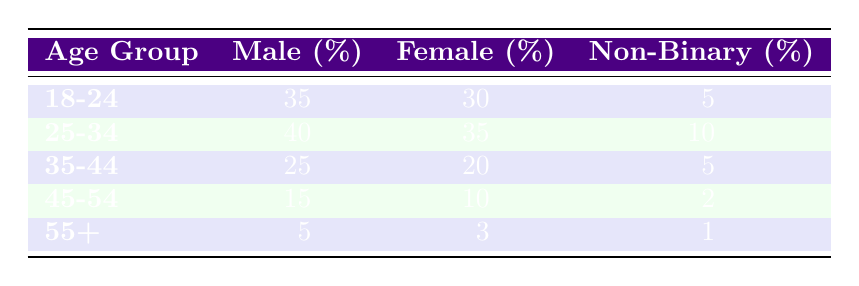What is the male participation rate in the 18-24 age group? The table shows the male participation percentage specifically for the 18-24 age group, which is listed directly in the table. According to the data, it is 35%.
Answer: 35% What is the female participation rate in the 45-54 age group? The table provides the female participation percentage for the 45-54 age group. It reads 10%.
Answer: 10% Which age group has the highest participation rate for non-binary individuals? By examining the non-binary participation percentages across all age groups, the 25-34 age group has the highest rate, at 10%.
Answer: 25-34 What is the difference in male participation rates between the 25-34 and 35-44 age groups? Male participation in the 25-34 age group is 40%, while it is 25% in the 35-44 age group. The difference between these two rates is calculated as 40% - 25% = 15%.
Answer: 15% Is the female participation rate in the 55+ age group higher than in the 45-54 age group? The female participation rate for the 55+ age group is 3%, and for the 45-54 age group, it is 10%. Since 3% is less than 10%, the statement is false.
Answer: No What is the average participation rate for males across all age groups? To find the average, we first add up the male participation rates: (35 + 40 + 25 + 15 + 5) = 120. Then, we divide that sum by the total number of age groups, which is 5. The average is therefore 120/5 = 24%.
Answer: 24% What is the total participation percentage of females in the 18-24 and 25-34 age groups combined? The female participation rates in the 18-24 and 25-34 age groups are 30% and 35%, respectively. By adding these two percentages together, we get 30% + 35% = 65%.
Answer: 65% Is the non-binary participation rate higher in the 35-44 age group compared to the 18-24 age group? The non-binary participation rate for the 35-44 age group is 5%, while for the 18-24 age group it is also 5%. Since the two rates are equal, the answer is no.
Answer: No What percentage of participants aged 45-54 are male? The percentage of male participants in the 45-54 age group is explicitly listed in the table as 15%.
Answer: 15% 